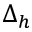<formula> <loc_0><loc_0><loc_500><loc_500>\Delta _ { h }</formula> 